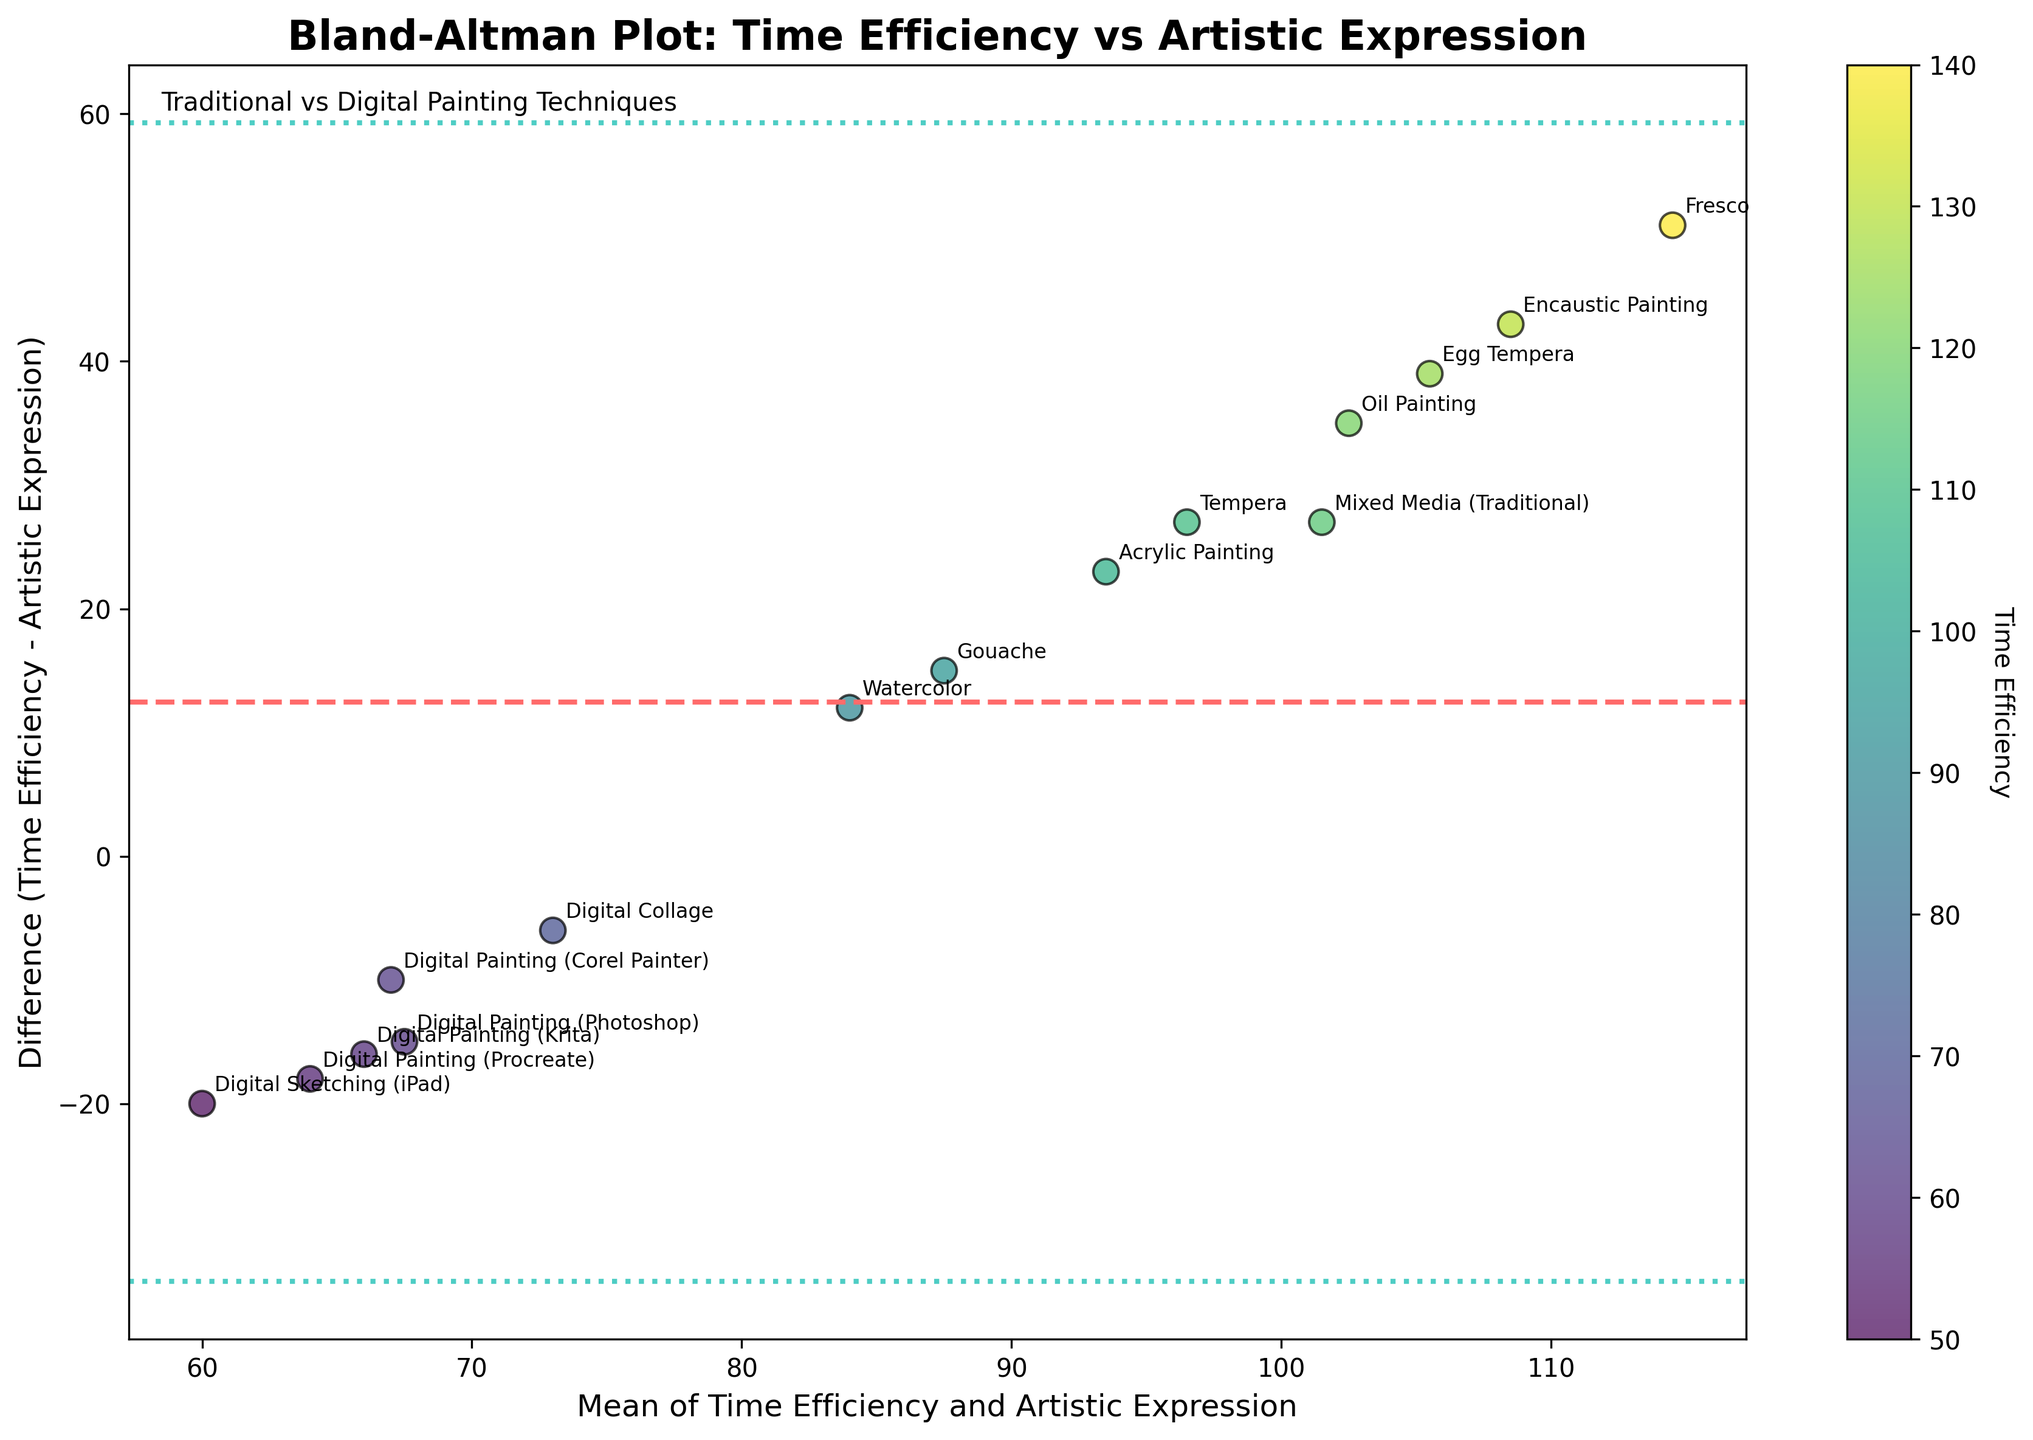How many data points are shown in the plot? By counting the number of scatter points on the plot, we see there are 15 points, each representing a different painting technique.
Answer: 15 What is the title of the plot? The title is displayed at the top of the plot. It reads "Bland-Altman Plot: Time Efficiency vs Artistic Expression".
Answer: Bland-Altman Plot: Time Efficiency vs Artistic Expression Which technique has the highest mean value of Time Efficiency and Artistic Expression? The technique with the highest mean value is identified by finding the highest point along the x-axis. For Fresco, the average is (140+89)/2=114.5, and it displays the highest mean value.
Answer: Fresco What is the mean difference between Time Efficiency and Artistic Expression? The mean difference is shown by the horizontal dashed line. Observing the plot, the line is approximately at 20.
Answer: ~20 Are there any techniques plotted below the lower limit of agreement? The lower limit of agreement is represented by the lower dotted line. No points are located below this line, so there aren't any techniques below the lower limit.
Answer: No Which digital painting technique has the lowest Time Efficiency? By identifying the digital techniques and observing their Time Efficiency, Digital Sketching (iPad) has the lowest Time Efficiency value of 50.
Answer: Digital Sketching (iPad) How are traditional and digital techniques represented in terms of color? The colors correspond to Time Efficiency, with the color bar showing the range from lower to higher values. Both traditional and digital techniques are represented using shades from the color map 'viridis'.
Answer: Shades of a color map Which technique has the smallest difference between Time Efficiency and Artistic Expression? The smallest difference is close to the most central point along the y-axis. For the Acrylic Painting technique, the difference is (105-82)=23, which is small compared to others.
Answer: Acrylic Painting What is the standard deviation range in this plot? The standard deviation range is visually indicated between the two dotted lines. These lines show mean ± 1.96 * sd. Observing the plot, the range is approximately between 5 and 35.
Answer: ~5 to ~35 Which technique has the largest positive difference between Time Efficiency and Artistic Expression? The technique with the largest positive difference can be found by looking for the highest point on the y-axis. For Fresco, the difference is (140-89)=51, the largest positive difference observed.
Answer: Fresco 